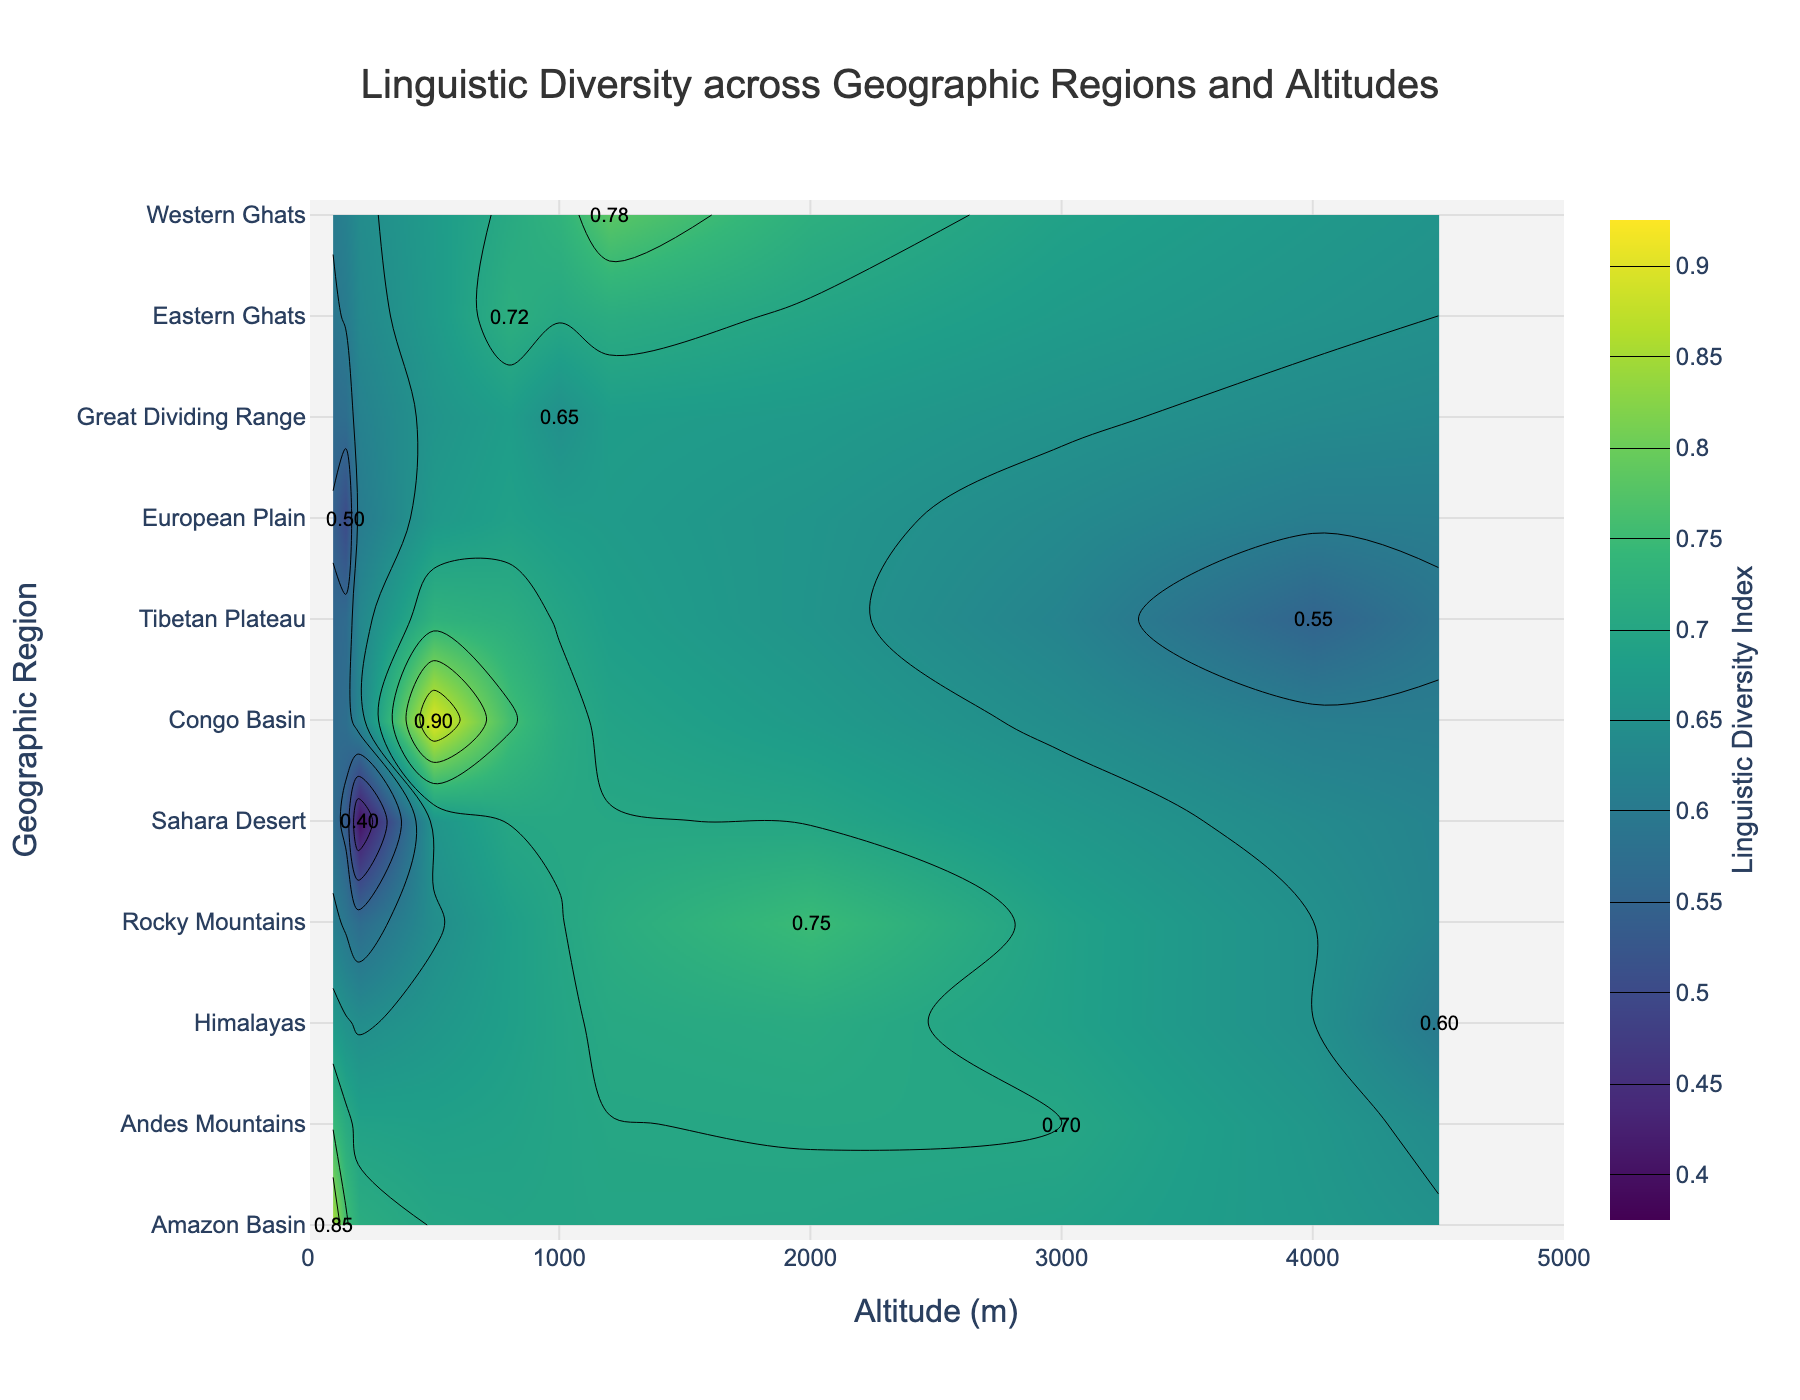What's the title of the plot? The title of the plot is located at the top center of the figure.
Answer: Linguistic Diversity across Geographic Regions and Altitudes What is the range of altitude presented in the x-axis? The x-axis label is "Altitude (m)" and runs horizontally; the range is indicated by the axis limits.
Answer: 0 to 5000 meters Which geographic region has the highest linguistic diversity index? Look at the colorbar indicating the linguistic diversity index and find the region associated with the highest value (0.9).
Answer: Congo Basin How many geographic regions have a linguistic diversity index of 0.75 or higher? Identify regions with a linguistic diversity index of 0.75 or higher using the color gradient and annotations.
Answer: 5 regions (Amazon Basin, Andes Mountains, Rocky Mountains, Congo Basin, Western Ghats) What is the linguistic diversity index of the European Plain? Find the European Plain on the y-axis and look at the corresponding value annotation.
Answer: 0.50 Compare the linguistic diversity index between the Andes Mountains and the Rocky Mountains. Which has a higher index? Locate both Andes Mountains and Rocky Mountains on the y-axis and compare their values.
Answer: Rocky Mountains (0.75) is higher than Andes Mountains (0.70) What is the difference in altitude between the Tibetan Plateau and the Great Dividing Range? Find both regions on the y-axis and identify their altitudes on the x-axis, then subtract the smaller altitude from the larger one.
Answer: 3000 meters (4000 - 1000) Which region has the lowest linguistic diversity index and what is its value? Identify the region and corresponding value by looking at the contour with the darkest color (representing the lowest value on the color scale).
Answer: Sahara Desert (0.40) What is the average linguistic diversity index of regions with an altitude above 2000 meters? First, identify all regions with altitudes above 2000 meters, then sum their linguistic diversity index values and divide by the number of these regions.
Answer: 0.65 (Average of Andes Mountains (0.70), Himalayas (0.60), Tibetan Plateau (0.55), and Rocky Mountains (0.75)) Describe how linguistic diversity changes with altitude. Examine patterns in the color gradients and annotations as altitude increases on the x-axis. Summarize generally whether diversity seems to increase, decrease, or fluctuate with altitude.
Answer: Generally decreases; higher altitudes (over 4000 meters) tend to have lower diversity 